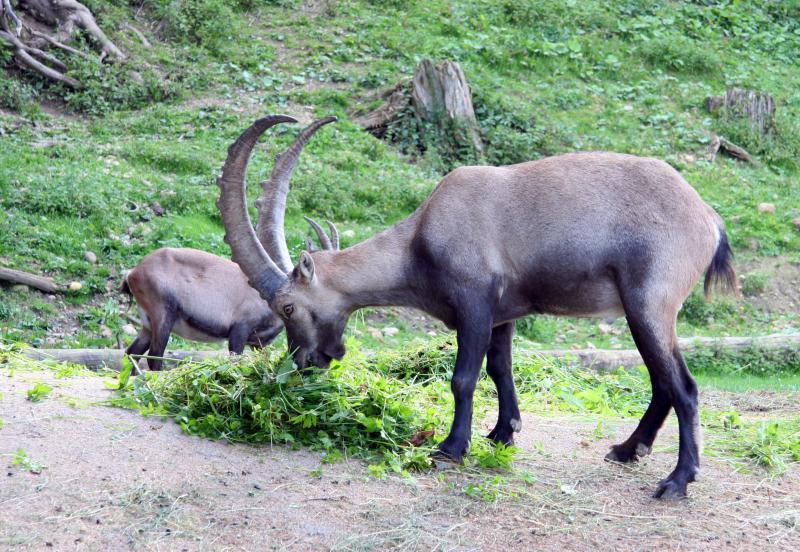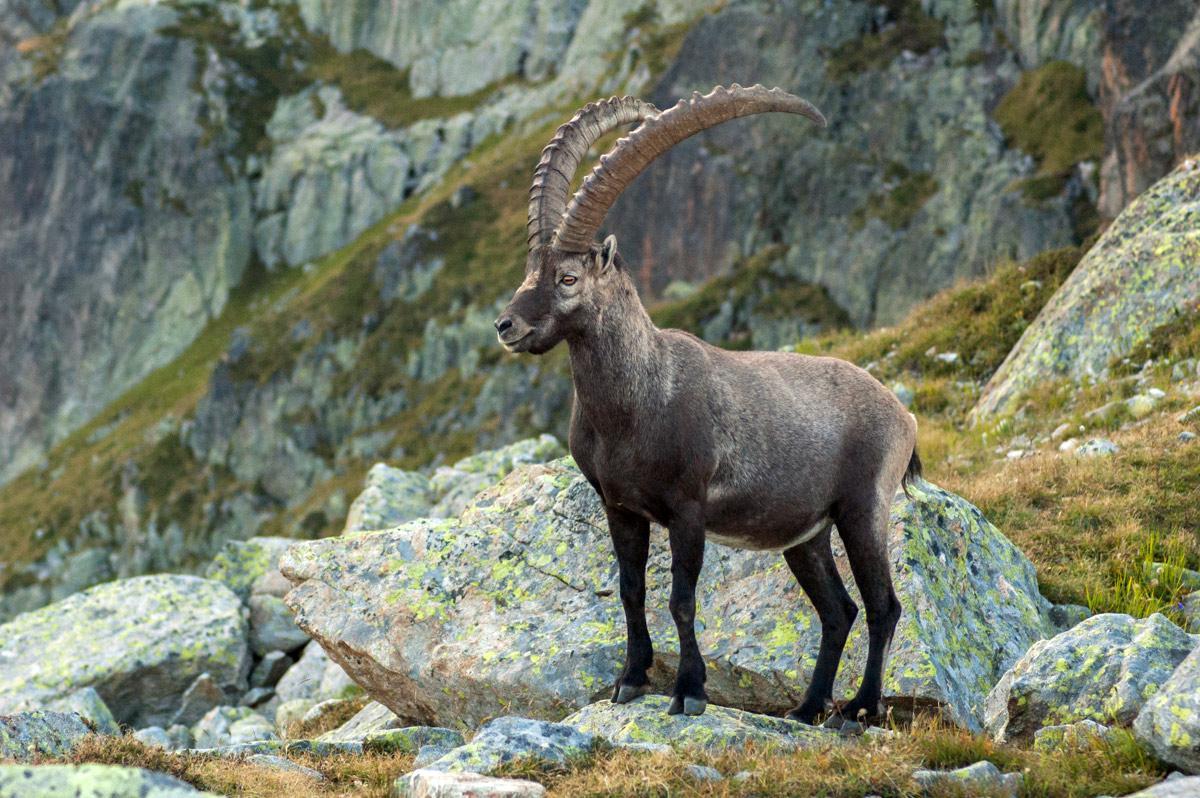The first image is the image on the left, the second image is the image on the right. For the images shown, is this caption "There are three antelopes in total." true? Answer yes or no. Yes. The first image is the image on the left, the second image is the image on the right. Examine the images to the left and right. Is the description "An image shows exactly one horned animal, which stands with body angled leftward and head angled rightward." accurate? Answer yes or no. No. 